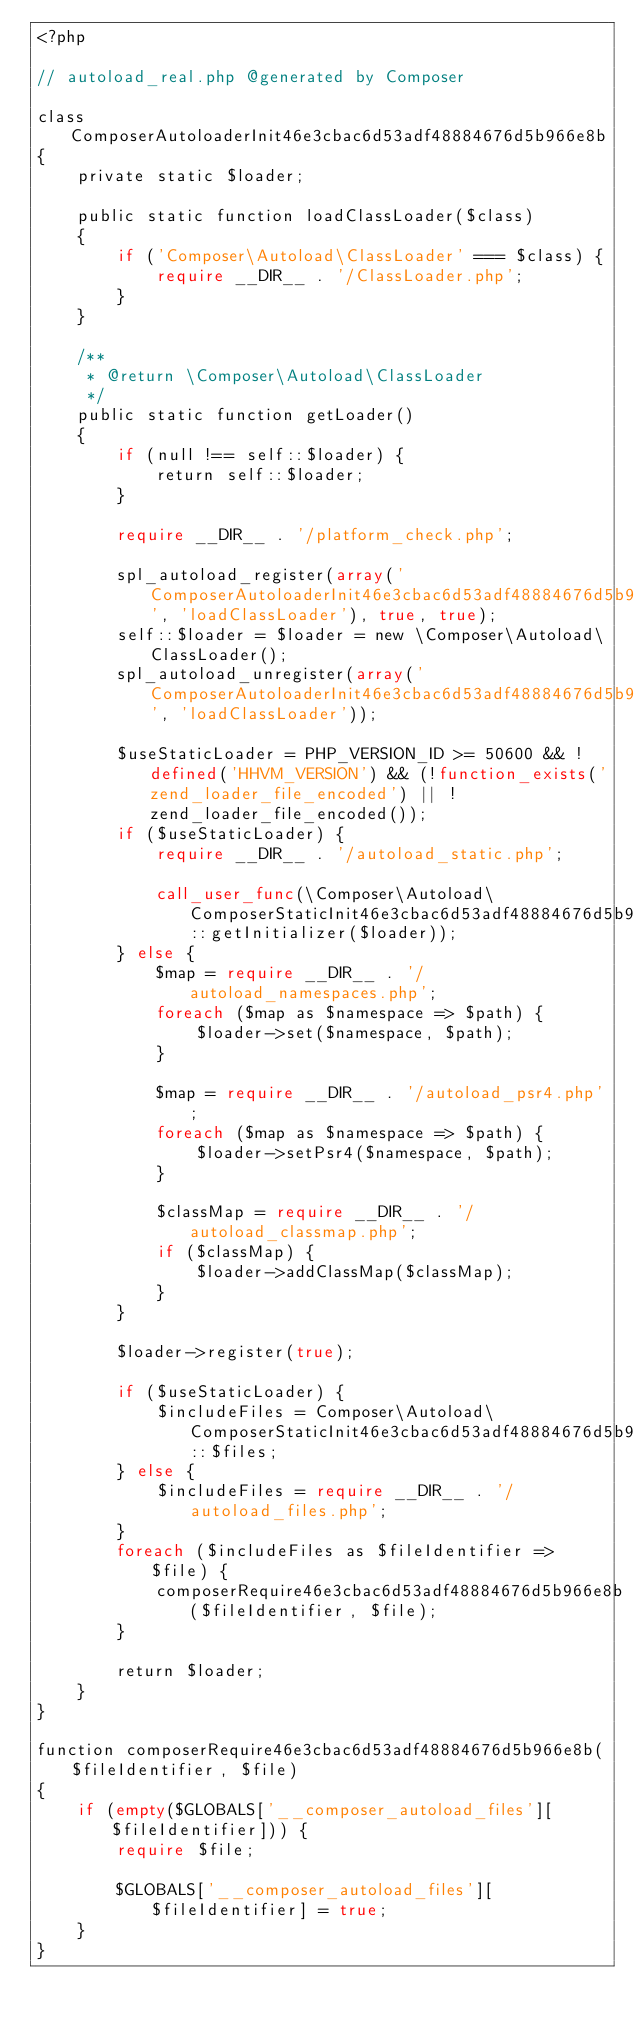Convert code to text. <code><loc_0><loc_0><loc_500><loc_500><_PHP_><?php

// autoload_real.php @generated by Composer

class ComposerAutoloaderInit46e3cbac6d53adf48884676d5b966e8b
{
    private static $loader;

    public static function loadClassLoader($class)
    {
        if ('Composer\Autoload\ClassLoader' === $class) {
            require __DIR__ . '/ClassLoader.php';
        }
    }

    /**
     * @return \Composer\Autoload\ClassLoader
     */
    public static function getLoader()
    {
        if (null !== self::$loader) {
            return self::$loader;
        }

        require __DIR__ . '/platform_check.php';

        spl_autoload_register(array('ComposerAutoloaderInit46e3cbac6d53adf48884676d5b966e8b', 'loadClassLoader'), true, true);
        self::$loader = $loader = new \Composer\Autoload\ClassLoader();
        spl_autoload_unregister(array('ComposerAutoloaderInit46e3cbac6d53adf48884676d5b966e8b', 'loadClassLoader'));

        $useStaticLoader = PHP_VERSION_ID >= 50600 && !defined('HHVM_VERSION') && (!function_exists('zend_loader_file_encoded') || !zend_loader_file_encoded());
        if ($useStaticLoader) {
            require __DIR__ . '/autoload_static.php';

            call_user_func(\Composer\Autoload\ComposerStaticInit46e3cbac6d53adf48884676d5b966e8b::getInitializer($loader));
        } else {
            $map = require __DIR__ . '/autoload_namespaces.php';
            foreach ($map as $namespace => $path) {
                $loader->set($namespace, $path);
            }

            $map = require __DIR__ . '/autoload_psr4.php';
            foreach ($map as $namespace => $path) {
                $loader->setPsr4($namespace, $path);
            }

            $classMap = require __DIR__ . '/autoload_classmap.php';
            if ($classMap) {
                $loader->addClassMap($classMap);
            }
        }

        $loader->register(true);

        if ($useStaticLoader) {
            $includeFiles = Composer\Autoload\ComposerStaticInit46e3cbac6d53adf48884676d5b966e8b::$files;
        } else {
            $includeFiles = require __DIR__ . '/autoload_files.php';
        }
        foreach ($includeFiles as $fileIdentifier => $file) {
            composerRequire46e3cbac6d53adf48884676d5b966e8b($fileIdentifier, $file);
        }

        return $loader;
    }
}

function composerRequire46e3cbac6d53adf48884676d5b966e8b($fileIdentifier, $file)
{
    if (empty($GLOBALS['__composer_autoload_files'][$fileIdentifier])) {
        require $file;

        $GLOBALS['__composer_autoload_files'][$fileIdentifier] = true;
    }
}
</code> 